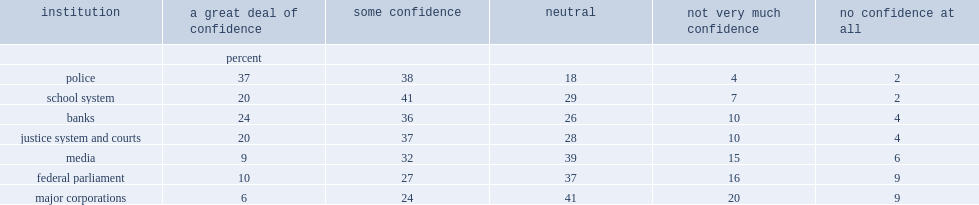What percent of canadians aged 15 and over indicated that they have a great deal or some confidence in police? 75. In 2013, what percent of canadians expressed a great deal or some confidence in the school system? 61. What percent of canadians had confidence in the media? 41. 